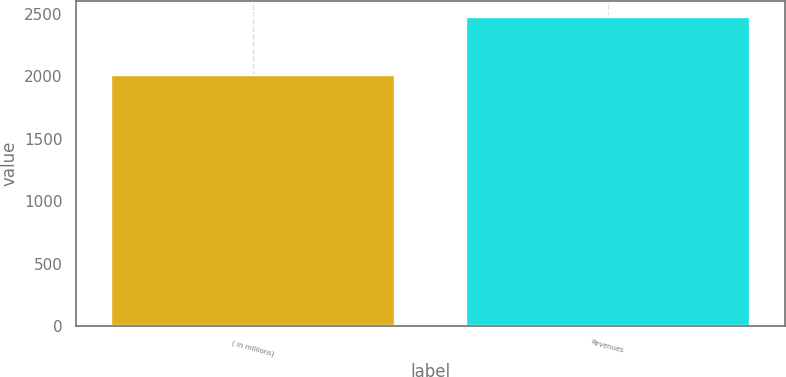Convert chart to OTSL. <chart><loc_0><loc_0><loc_500><loc_500><bar_chart><fcel>( in millions)<fcel>Revenues<nl><fcel>2006<fcel>2475<nl></chart> 